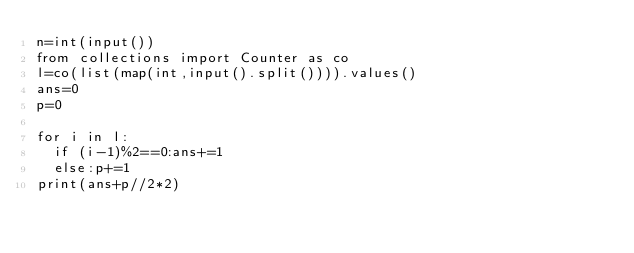Convert code to text. <code><loc_0><loc_0><loc_500><loc_500><_Python_>n=int(input())
from collections import Counter as co
l=co(list(map(int,input().split()))).values()
ans=0
p=0

for i in l:
  if (i-1)%2==0:ans+=1
  else:p+=1
print(ans+p//2*2)</code> 